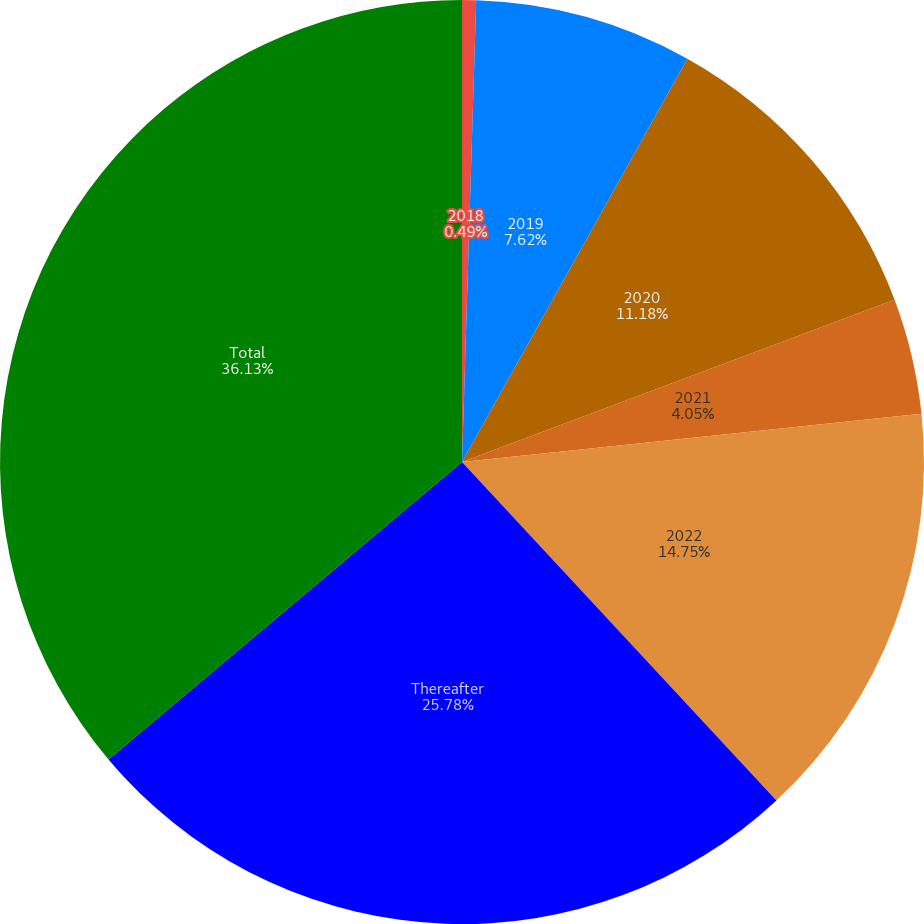<chart> <loc_0><loc_0><loc_500><loc_500><pie_chart><fcel>2018<fcel>2019<fcel>2020<fcel>2021<fcel>2022<fcel>Thereafter<fcel>Total<nl><fcel>0.49%<fcel>7.62%<fcel>11.18%<fcel>4.05%<fcel>14.75%<fcel>25.78%<fcel>36.14%<nl></chart> 